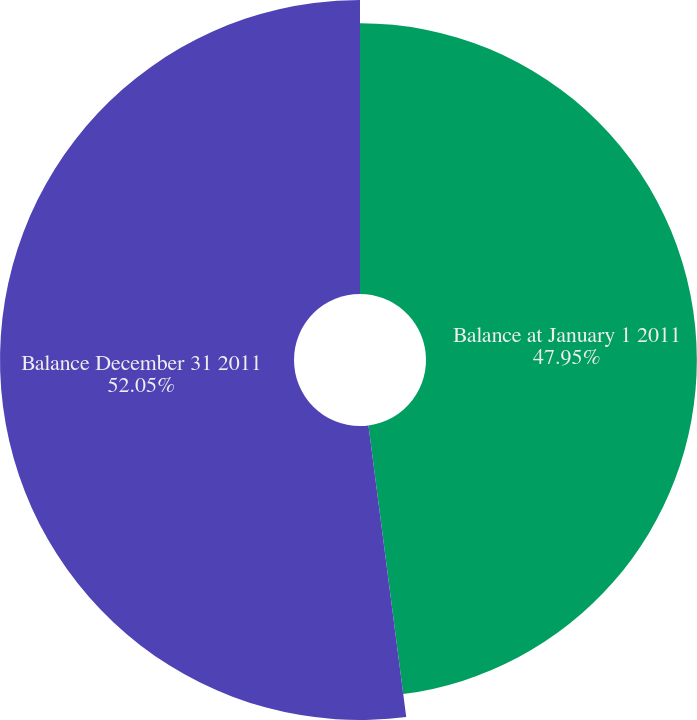Convert chart to OTSL. <chart><loc_0><loc_0><loc_500><loc_500><pie_chart><fcel>Balance at January 1 2011<fcel>Balance December 31 2011<nl><fcel>47.95%<fcel>52.05%<nl></chart> 